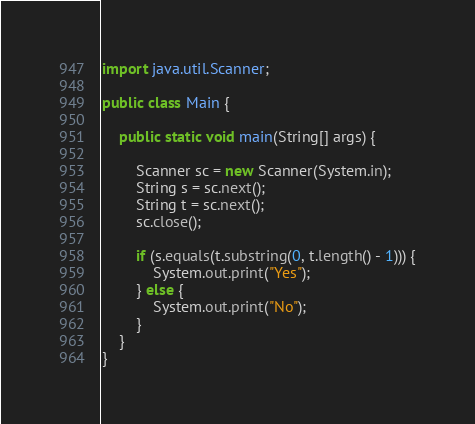Convert code to text. <code><loc_0><loc_0><loc_500><loc_500><_Java_>import java.util.Scanner;

public class Main {

	public static void main(String[] args) {

		Scanner sc = new Scanner(System.in);
		String s = sc.next();
		String t = sc.next();
		sc.close();

		if (s.equals(t.substring(0, t.length() - 1))) {
			System.out.print("Yes");
		} else {
			System.out.print("No");
		}
	}
}
</code> 